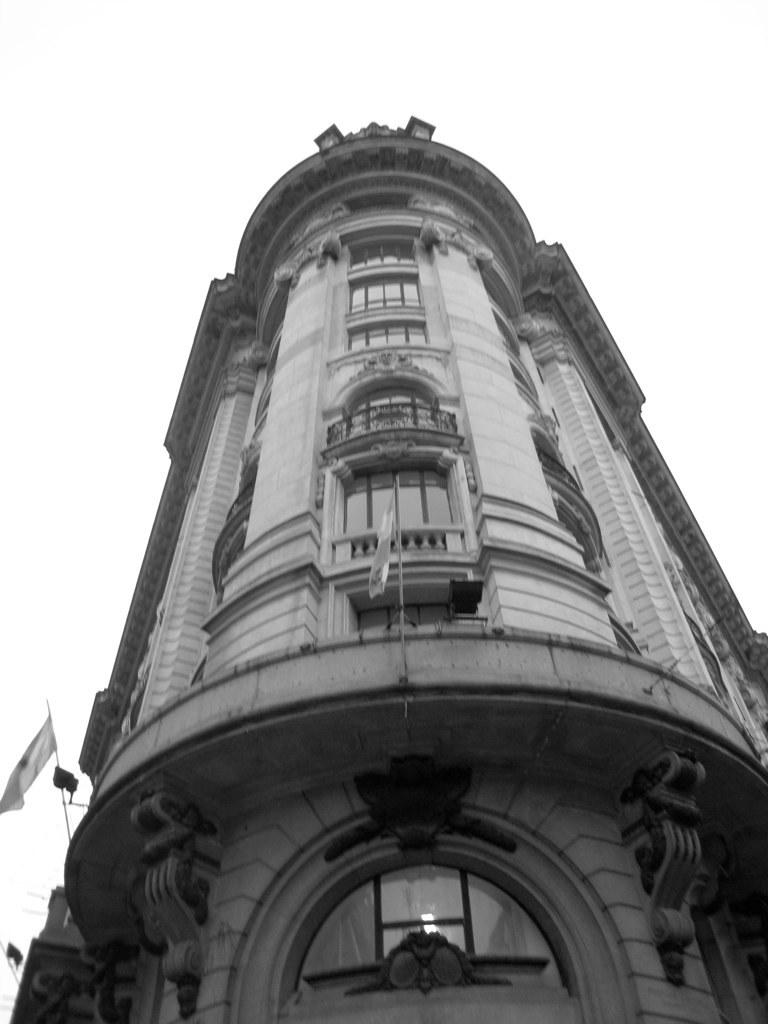What is the main subject in the center of the image? There is a building in the center of the image. What else can be seen in the image besides the building? There are flags in the image. What can be seen in the background of the image? The sky is visible in the background of the image. What is the process of making a profit from the attraction in the image? There is no attraction present in the image, so it is not possible to discuss the process of making a profit from it. 